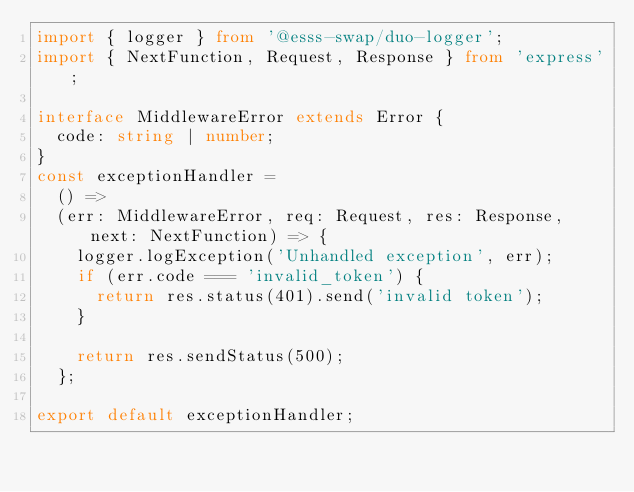<code> <loc_0><loc_0><loc_500><loc_500><_TypeScript_>import { logger } from '@esss-swap/duo-logger';
import { NextFunction, Request, Response } from 'express';

interface MiddlewareError extends Error {
  code: string | number;
}
const exceptionHandler =
  () =>
  (err: MiddlewareError, req: Request, res: Response, next: NextFunction) => {
    logger.logException('Unhandled exception', err);
    if (err.code === 'invalid_token') {
      return res.status(401).send('invalid token');
    }

    return res.sendStatus(500);
  };

export default exceptionHandler;
</code> 